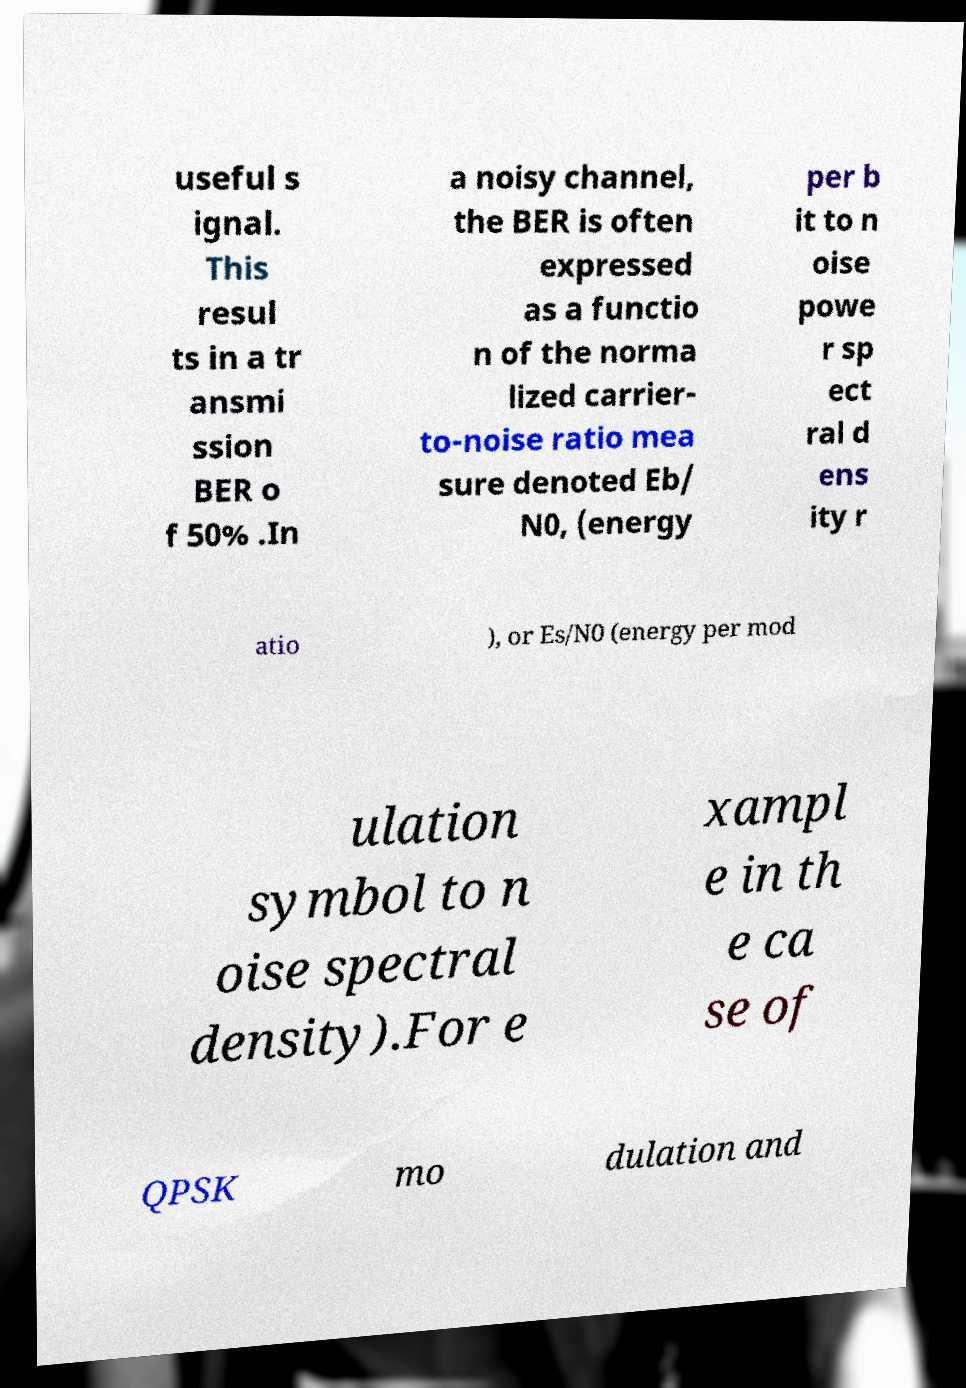Please read and relay the text visible in this image. What does it say? useful s ignal. This resul ts in a tr ansmi ssion BER o f 50% .In a noisy channel, the BER is often expressed as a functio n of the norma lized carrier- to-noise ratio mea sure denoted Eb/ N0, (energy per b it to n oise powe r sp ect ral d ens ity r atio ), or Es/N0 (energy per mod ulation symbol to n oise spectral density).For e xampl e in th e ca se of QPSK mo dulation and 